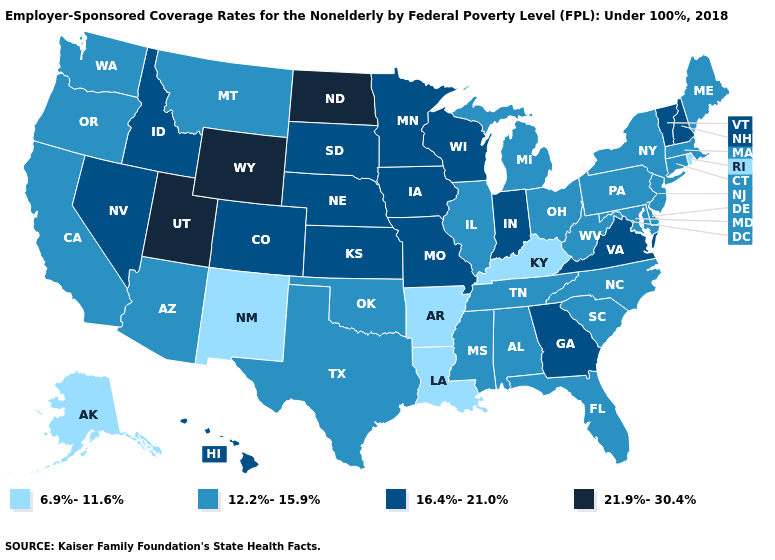What is the lowest value in the USA?
Concise answer only. 6.9%-11.6%. Among the states that border Minnesota , which have the highest value?
Keep it brief. North Dakota. Name the states that have a value in the range 16.4%-21.0%?
Quick response, please. Colorado, Georgia, Hawaii, Idaho, Indiana, Iowa, Kansas, Minnesota, Missouri, Nebraska, Nevada, New Hampshire, South Dakota, Vermont, Virginia, Wisconsin. Name the states that have a value in the range 21.9%-30.4%?
Give a very brief answer. North Dakota, Utah, Wyoming. Does Connecticut have the lowest value in the USA?
Write a very short answer. No. Which states have the highest value in the USA?
Concise answer only. North Dakota, Utah, Wyoming. Among the states that border Michigan , does Indiana have the highest value?
Quick response, please. Yes. What is the lowest value in the USA?
Write a very short answer. 6.9%-11.6%. What is the lowest value in the USA?
Keep it brief. 6.9%-11.6%. What is the value of Arkansas?
Write a very short answer. 6.9%-11.6%. Does New Hampshire have a lower value than New York?
Write a very short answer. No. What is the value of Kansas?
Keep it brief. 16.4%-21.0%. Does the map have missing data?
Quick response, please. No. Among the states that border New Mexico , does Utah have the lowest value?
Write a very short answer. No. Among the states that border Texas , which have the highest value?
Write a very short answer. Oklahoma. 